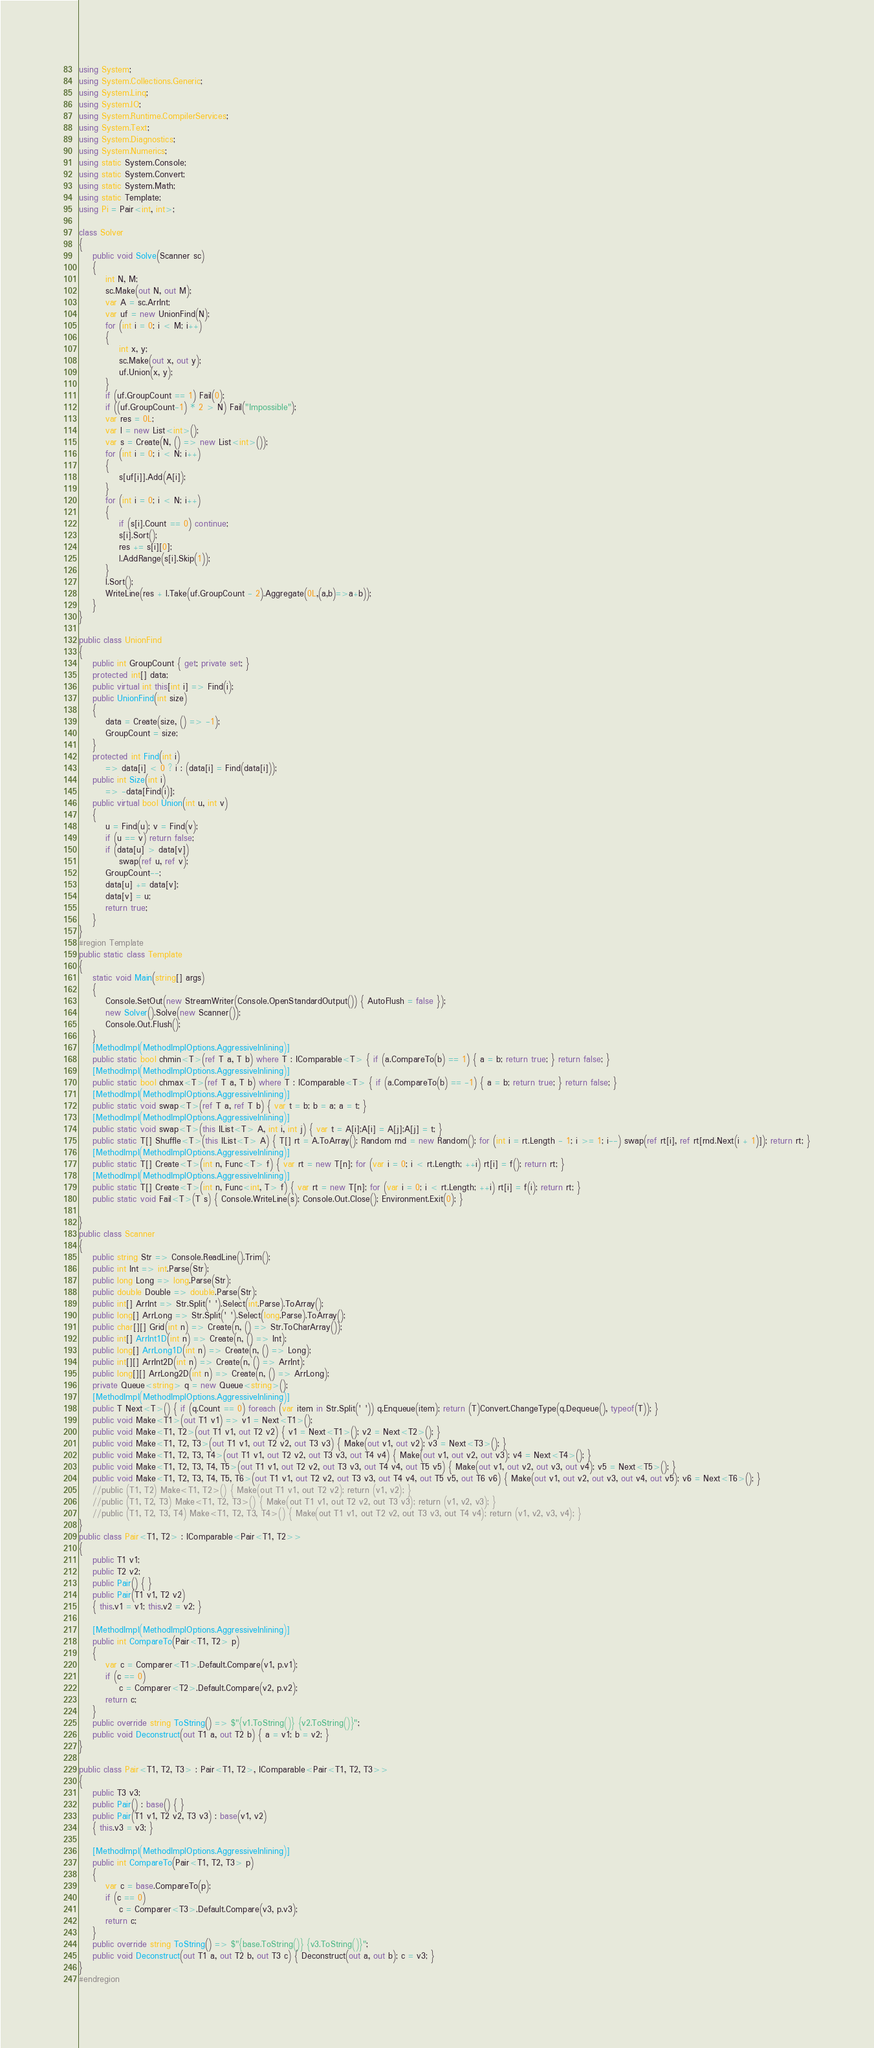<code> <loc_0><loc_0><loc_500><loc_500><_C#_>using System;
using System.Collections.Generic;
using System.Linq;
using System.IO;
using System.Runtime.CompilerServices;
using System.Text;
using System.Diagnostics;
using System.Numerics;
using static System.Console;
using static System.Convert;
using static System.Math;
using static Template;
using Pi = Pair<int, int>;

class Solver
{
    public void Solve(Scanner sc)
    {
        int N, M;
        sc.Make(out N, out M);
        var A = sc.ArrInt;
        var uf = new UnionFind(N);
        for (int i = 0; i < M; i++)
        {
            int x, y;
            sc.Make(out x, out y);
            uf.Union(x, y);
        }
        if (uf.GroupCount == 1) Fail(0);
        if ((uf.GroupCount-1) * 2 > N) Fail("Impossible");
        var res = 0L;
        var l = new List<int>();
        var s = Create(N, () => new List<int>());
        for (int i = 0; i < N; i++)
        {
            s[uf[i]].Add(A[i]);
        }
        for (int i = 0; i < N; i++)
        {
            if (s[i].Count == 0) continue;
            s[i].Sort();
            res += s[i][0];
            l.AddRange(s[i].Skip(1));
        }
        l.Sort();
        WriteLine(res + l.Take(uf.GroupCount - 2).Aggregate(0L,(a,b)=>a+b));
    }
}

public class UnionFind
{
    public int GroupCount { get; private set; }
    protected int[] data;
    public virtual int this[int i] => Find(i);
    public UnionFind(int size)
    {
        data = Create(size, () => -1);
        GroupCount = size;
    }
    protected int Find(int i)
        => data[i] < 0 ? i : (data[i] = Find(data[i]));
    public int Size(int i)
        => -data[Find(i)];
    public virtual bool Union(int u, int v)
    {
        u = Find(u); v = Find(v);
        if (u == v) return false;
        if (data[u] > data[v])
            swap(ref u, ref v);
        GroupCount--;
        data[u] += data[v];
        data[v] = u;
        return true;
    }
}
#region Template
public static class Template
{
    static void Main(string[] args)
    {
        Console.SetOut(new StreamWriter(Console.OpenStandardOutput()) { AutoFlush = false });
        new Solver().Solve(new Scanner());
        Console.Out.Flush();
    }
    [MethodImpl(MethodImplOptions.AggressiveInlining)]
    public static bool chmin<T>(ref T a, T b) where T : IComparable<T> { if (a.CompareTo(b) == 1) { a = b; return true; } return false; }
    [MethodImpl(MethodImplOptions.AggressiveInlining)]
    public static bool chmax<T>(ref T a, T b) where T : IComparable<T> { if (a.CompareTo(b) == -1) { a = b; return true; } return false; }
    [MethodImpl(MethodImplOptions.AggressiveInlining)]
    public static void swap<T>(ref T a, ref T b) { var t = b; b = a; a = t; }
    [MethodImpl(MethodImplOptions.AggressiveInlining)]
    public static void swap<T>(this IList<T> A, int i, int j) { var t = A[i];A[i] = A[j];A[j] = t; }
    public static T[] Shuffle<T>(this IList<T> A) { T[] rt = A.ToArray(); Random rnd = new Random(); for (int i = rt.Length - 1; i >= 1; i--) swap(ref rt[i], ref rt[rnd.Next(i + 1)]); return rt; }
    [MethodImpl(MethodImplOptions.AggressiveInlining)]
    public static T[] Create<T>(int n, Func<T> f) { var rt = new T[n]; for (var i = 0; i < rt.Length; ++i) rt[i] = f(); return rt; }
    [MethodImpl(MethodImplOptions.AggressiveInlining)]
    public static T[] Create<T>(int n, Func<int, T> f) { var rt = new T[n]; for (var i = 0; i < rt.Length; ++i) rt[i] = f(i); return rt; }
    public static void Fail<T>(T s) { Console.WriteLine(s); Console.Out.Close(); Environment.Exit(0); }

}
public class Scanner
{
    public string Str => Console.ReadLine().Trim();
    public int Int => int.Parse(Str);
    public long Long => long.Parse(Str);
    public double Double => double.Parse(Str);
    public int[] ArrInt => Str.Split(' ').Select(int.Parse).ToArray();
    public long[] ArrLong => Str.Split(' ').Select(long.Parse).ToArray();
    public char[][] Grid(int n) => Create(n, () => Str.ToCharArray());
    public int[] ArrInt1D(int n) => Create(n, () => Int);
    public long[] ArrLong1D(int n) => Create(n, () => Long);
    public int[][] ArrInt2D(int n) => Create(n, () => ArrInt);
    public long[][] ArrLong2D(int n) => Create(n, () => ArrLong);
    private Queue<string> q = new Queue<string>();
    [MethodImpl(MethodImplOptions.AggressiveInlining)]
    public T Next<T>() { if (q.Count == 0) foreach (var item in Str.Split(' ')) q.Enqueue(item); return (T)Convert.ChangeType(q.Dequeue(), typeof(T)); }
    public void Make<T1>(out T1 v1) => v1 = Next<T1>();
    public void Make<T1, T2>(out T1 v1, out T2 v2) { v1 = Next<T1>(); v2 = Next<T2>(); }
    public void Make<T1, T2, T3>(out T1 v1, out T2 v2, out T3 v3) { Make(out v1, out v2); v3 = Next<T3>(); }
    public void Make<T1, T2, T3, T4>(out T1 v1, out T2 v2, out T3 v3, out T4 v4) { Make(out v1, out v2, out v3); v4 = Next<T4>(); }
    public void Make<T1, T2, T3, T4, T5>(out T1 v1, out T2 v2, out T3 v3, out T4 v4, out T5 v5) { Make(out v1, out v2, out v3, out v4); v5 = Next<T5>(); }
    public void Make<T1, T2, T3, T4, T5, T6>(out T1 v1, out T2 v2, out T3 v3, out T4 v4, out T5 v5, out T6 v6) { Make(out v1, out v2, out v3, out v4, out v5); v6 = Next<T6>(); }
    //public (T1, T2) Make<T1, T2>() { Make(out T1 v1, out T2 v2); return (v1, v2); }
    //public (T1, T2, T3) Make<T1, T2, T3>() { Make(out T1 v1, out T2 v2, out T3 v3); return (v1, v2, v3); }
    //public (T1, T2, T3, T4) Make<T1, T2, T3, T4>() { Make(out T1 v1, out T2 v2, out T3 v3, out T4 v4); return (v1, v2, v3, v4); }
}
public class Pair<T1, T2> : IComparable<Pair<T1, T2>>
{
    public T1 v1;
    public T2 v2;
    public Pair() { }
    public Pair(T1 v1, T2 v2)
    { this.v1 = v1; this.v2 = v2; }

    [MethodImpl(MethodImplOptions.AggressiveInlining)]
    public int CompareTo(Pair<T1, T2> p)
    {
        var c = Comparer<T1>.Default.Compare(v1, p.v1);
        if (c == 0)
            c = Comparer<T2>.Default.Compare(v2, p.v2);
        return c;
    }
    public override string ToString() => $"{v1.ToString()} {v2.ToString()}";
    public void Deconstruct(out T1 a, out T2 b) { a = v1; b = v2; }
}

public class Pair<T1, T2, T3> : Pair<T1, T2>, IComparable<Pair<T1, T2, T3>>
{
    public T3 v3;
    public Pair() : base() { }
    public Pair(T1 v1, T2 v2, T3 v3) : base(v1, v2)
    { this.v3 = v3; }

    [MethodImpl(MethodImplOptions.AggressiveInlining)]
    public int CompareTo(Pair<T1, T2, T3> p)
    {
        var c = base.CompareTo(p);
        if (c == 0)
            c = Comparer<T3>.Default.Compare(v3, p.v3);
        return c;
    }
    public override string ToString() => $"{base.ToString()} {v3.ToString()}";
    public void Deconstruct(out T1 a, out T2 b, out T3 c) { Deconstruct(out a, out b); c = v3; }
}
#endregion</code> 